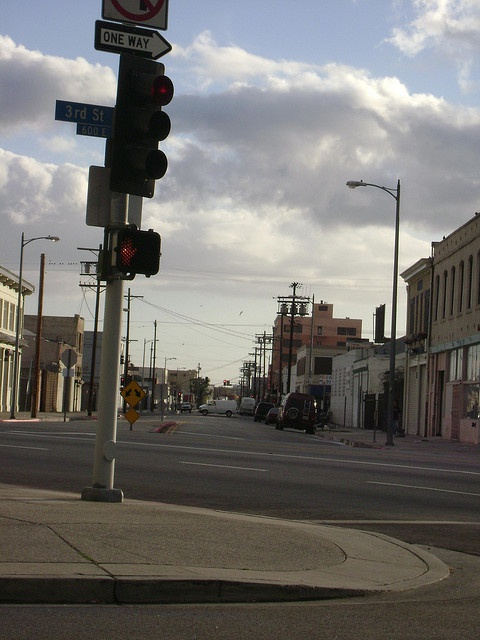Describe the objects in this image and their specific colors. I can see traffic light in darkgray, black, gray, and lightgray tones, traffic light in darkgray, black, maroon, brown, and gray tones, truck in darkgray, black, and gray tones, truck in darkgray, gray, and black tones, and car in darkgray, black, and gray tones in this image. 